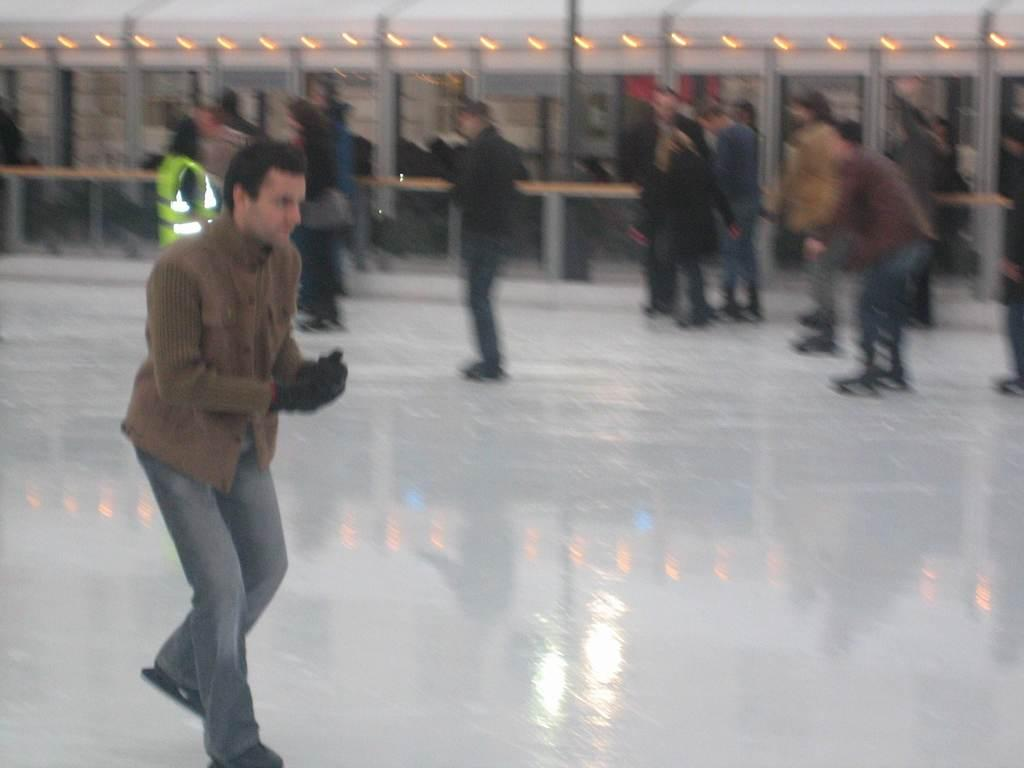What are the people in the image doing? The people in the image are skating on the ice. Can you describe the man in the foreground of the image? The man in the foreground of the image is skating. What can be observed about the background of the image? The background of the image is blurred. How many pigs can be seen skating in the image? There are no pigs present in the image; it features people skating on the ice. What type of loss is being experienced by the people in the image? There is no indication of loss in the image; it shows people skating on the ice and enjoying themselves. 